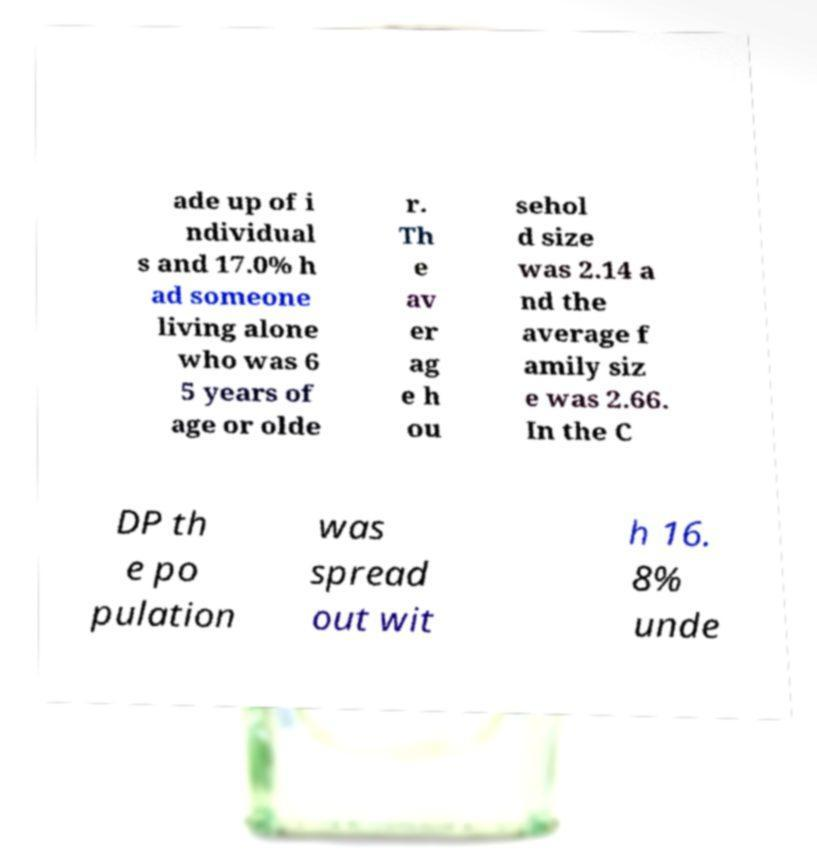I need the written content from this picture converted into text. Can you do that? ade up of i ndividual s and 17.0% h ad someone living alone who was 6 5 years of age or olde r. Th e av er ag e h ou sehol d size was 2.14 a nd the average f amily siz e was 2.66. In the C DP th e po pulation was spread out wit h 16. 8% unde 